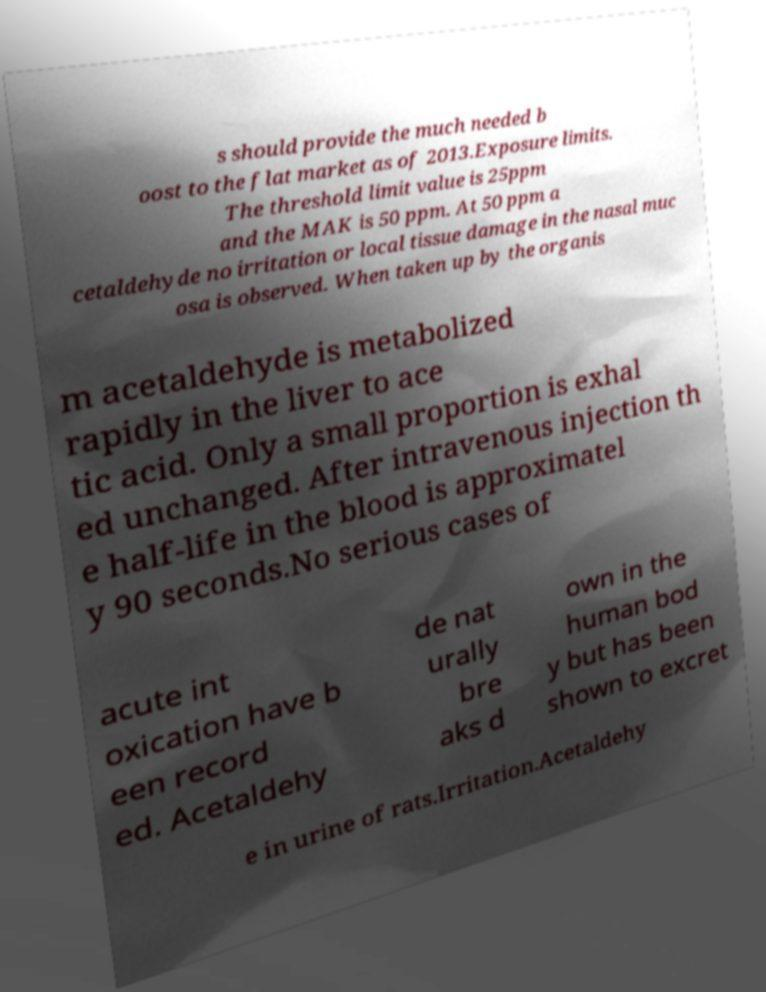Could you extract and type out the text from this image? s should provide the much needed b oost to the flat market as of 2013.Exposure limits. The threshold limit value is 25ppm and the MAK is 50 ppm. At 50 ppm a cetaldehyde no irritation or local tissue damage in the nasal muc osa is observed. When taken up by the organis m acetaldehyde is metabolized rapidly in the liver to ace tic acid. Only a small proportion is exhal ed unchanged. After intravenous injection th e half-life in the blood is approximatel y 90 seconds.No serious cases of acute int oxication have b een record ed. Acetaldehy de nat urally bre aks d own in the human bod y but has been shown to excret e in urine of rats.Irritation.Acetaldehy 